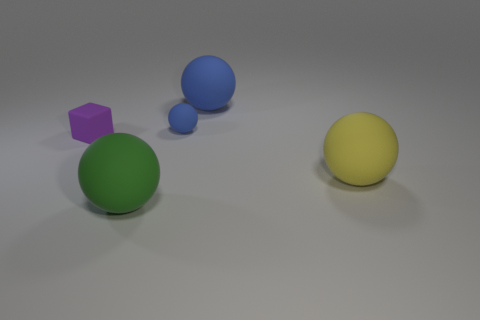Subtract 1 balls. How many balls are left? 3 Add 4 blue matte objects. How many objects exist? 9 Subtract all cyan spheres. Subtract all blue cylinders. How many spheres are left? 4 Subtract all spheres. How many objects are left? 1 Subtract all large blue matte objects. Subtract all rubber balls. How many objects are left? 0 Add 5 large blue objects. How many large blue objects are left? 6 Add 1 yellow rubber balls. How many yellow rubber balls exist? 2 Subtract 0 yellow blocks. How many objects are left? 5 